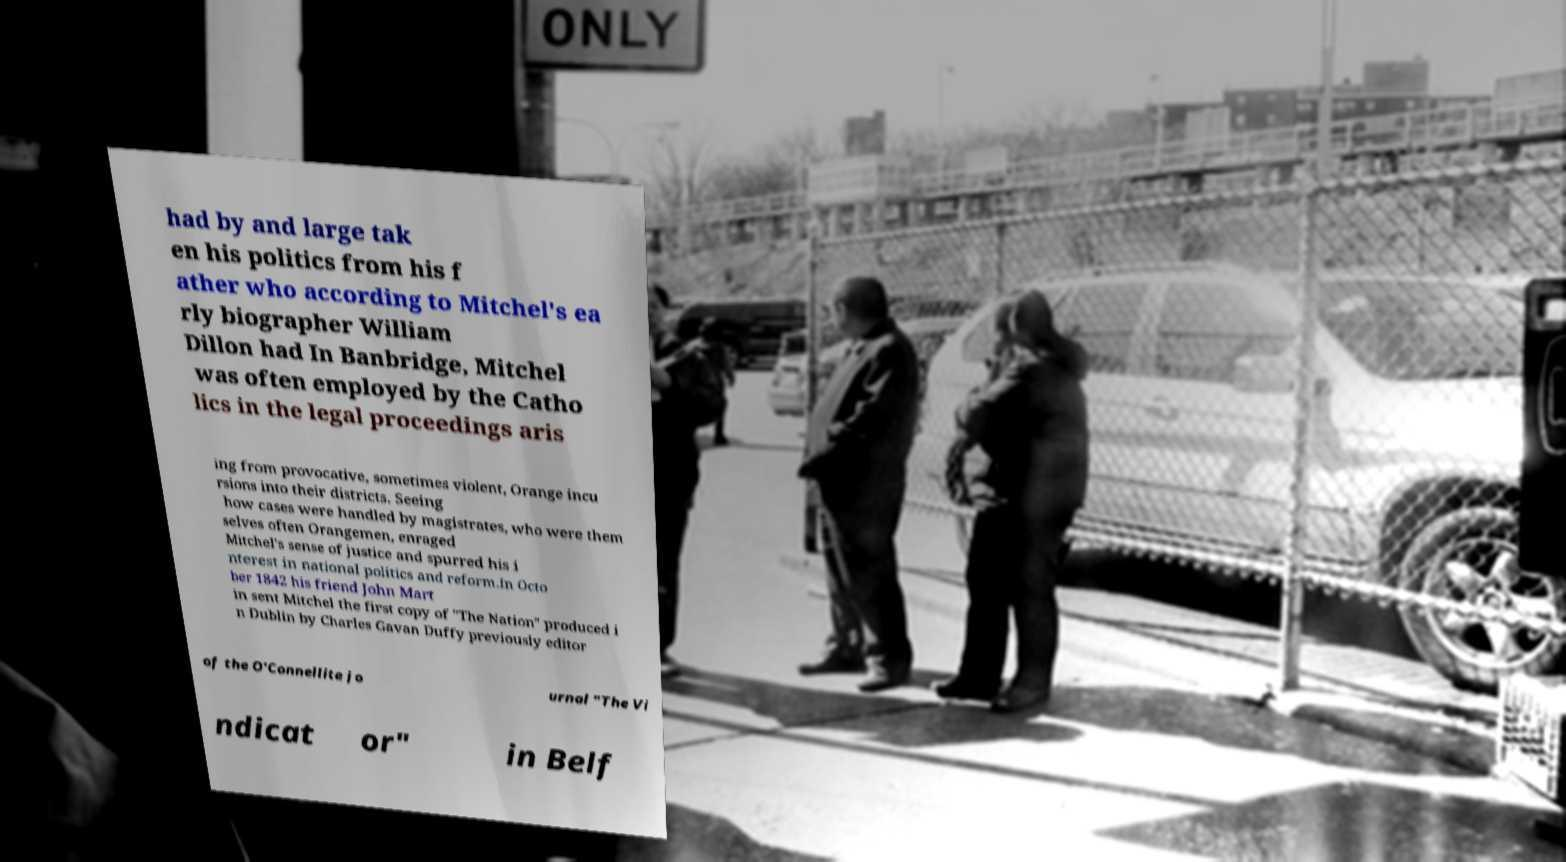There's text embedded in this image that I need extracted. Can you transcribe it verbatim? had by and large tak en his politics from his f ather who according to Mitchel's ea rly biographer William Dillon had In Banbridge, Mitchel was often employed by the Catho lics in the legal proceedings aris ing from provocative, sometimes violent, Orange incu rsions into their districts. Seeing how cases were handled by magistrates, who were them selves often Orangemen, enraged Mitchel's sense of justice and spurred his i nterest in national politics and reform.In Octo ber 1842 his friend John Mart in sent Mitchel the first copy of "The Nation" produced i n Dublin by Charles Gavan Duffy previously editor of the O'Connellite jo urnal "The Vi ndicat or" in Belf 